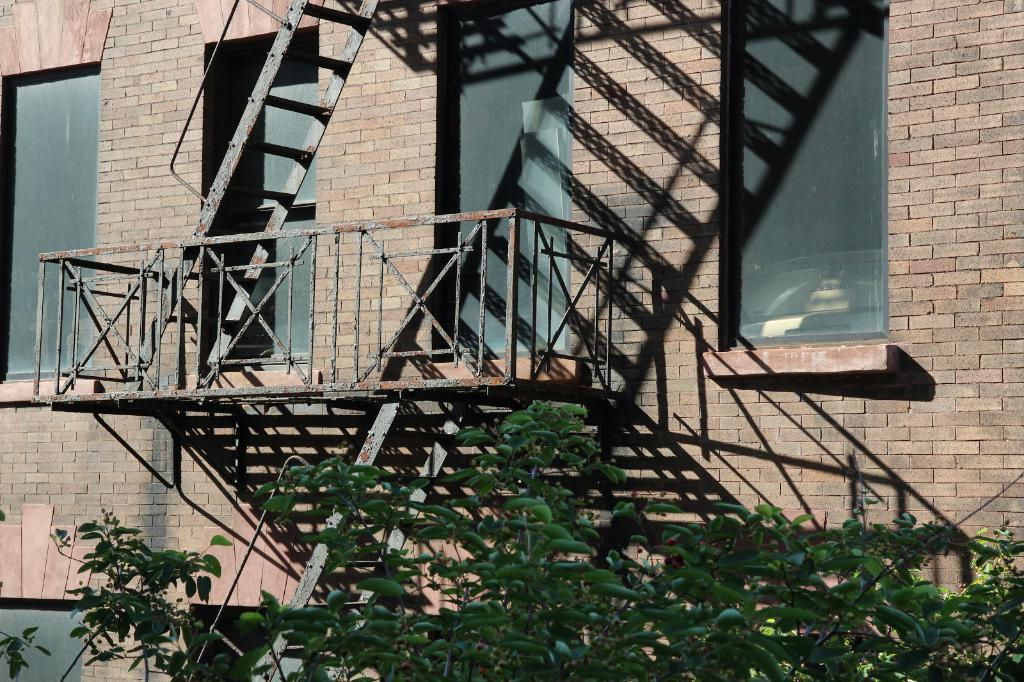What type of structure is visible in the image? There is a building in the image. What features can be seen on the building? The building has windows and a steel staircase. What is located in front of the building? There are trees in front of the building. What type of recess activity is taking place in front of the building? There is no recess activity or basketball game visible in the image; it only shows a building with trees in front of it. Can you tell me what the grandfather is doing in the image? There is no grandfather or any person present in the image; it only features a building and trees. 